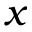Convert formula to latex. <formula><loc_0><loc_0><loc_500><loc_500>x</formula> 